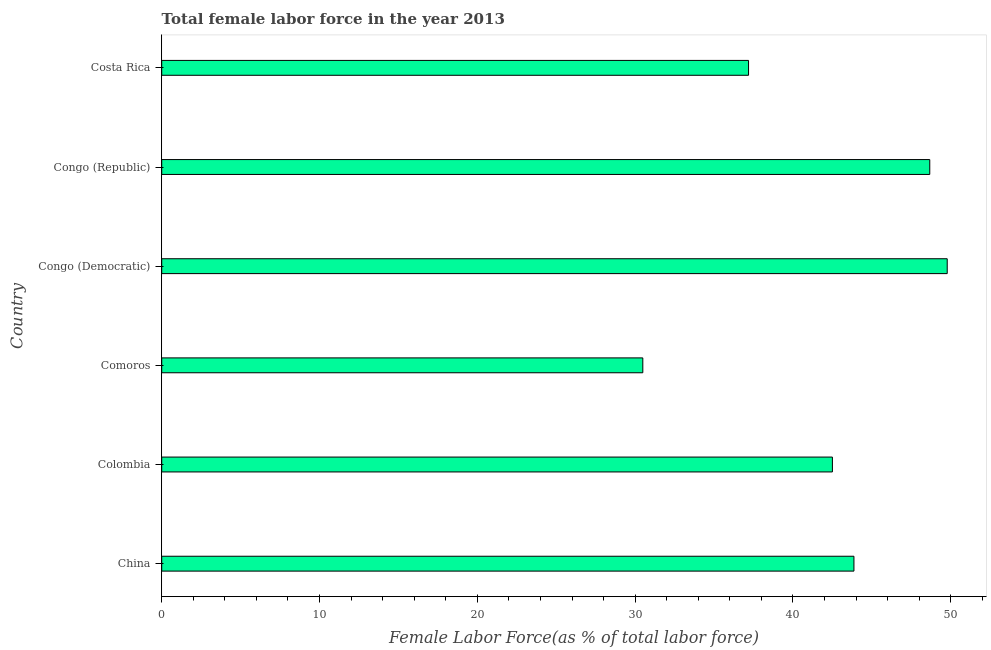Does the graph contain any zero values?
Provide a succinct answer. No. Does the graph contain grids?
Your answer should be very brief. No. What is the title of the graph?
Ensure brevity in your answer.  Total female labor force in the year 2013. What is the label or title of the X-axis?
Offer a terse response. Female Labor Force(as % of total labor force). What is the total female labor force in Congo (Democratic)?
Give a very brief answer. 49.77. Across all countries, what is the maximum total female labor force?
Your response must be concise. 49.77. Across all countries, what is the minimum total female labor force?
Offer a very short reply. 30.49. In which country was the total female labor force maximum?
Your answer should be compact. Congo (Democratic). In which country was the total female labor force minimum?
Provide a short and direct response. Comoros. What is the sum of the total female labor force?
Offer a very short reply. 252.48. What is the difference between the total female labor force in Colombia and Congo (Republic)?
Make the answer very short. -6.17. What is the average total female labor force per country?
Provide a short and direct response. 42.08. What is the median total female labor force?
Offer a terse response. 43.18. What is the ratio of the total female labor force in China to that in Congo (Democratic)?
Provide a short and direct response. 0.88. What is the difference between the highest and the second highest total female labor force?
Offer a very short reply. 1.11. Is the sum of the total female labor force in Colombia and Costa Rica greater than the maximum total female labor force across all countries?
Keep it short and to the point. Yes. What is the difference between the highest and the lowest total female labor force?
Give a very brief answer. 19.29. In how many countries, is the total female labor force greater than the average total female labor force taken over all countries?
Your answer should be very brief. 4. Are the values on the major ticks of X-axis written in scientific E-notation?
Ensure brevity in your answer.  No. What is the Female Labor Force(as % of total labor force) in China?
Your response must be concise. 43.86. What is the Female Labor Force(as % of total labor force) of Colombia?
Keep it short and to the point. 42.5. What is the Female Labor Force(as % of total labor force) in Comoros?
Give a very brief answer. 30.49. What is the Female Labor Force(as % of total labor force) of Congo (Democratic)?
Your answer should be compact. 49.77. What is the Female Labor Force(as % of total labor force) of Congo (Republic)?
Provide a short and direct response. 48.67. What is the Female Labor Force(as % of total labor force) of Costa Rica?
Your answer should be very brief. 37.19. What is the difference between the Female Labor Force(as % of total labor force) in China and Colombia?
Your answer should be very brief. 1.36. What is the difference between the Female Labor Force(as % of total labor force) in China and Comoros?
Keep it short and to the point. 13.38. What is the difference between the Female Labor Force(as % of total labor force) in China and Congo (Democratic)?
Your response must be concise. -5.91. What is the difference between the Female Labor Force(as % of total labor force) in China and Congo (Republic)?
Your response must be concise. -4.8. What is the difference between the Female Labor Force(as % of total labor force) in China and Costa Rica?
Make the answer very short. 6.68. What is the difference between the Female Labor Force(as % of total labor force) in Colombia and Comoros?
Offer a terse response. 12.01. What is the difference between the Female Labor Force(as % of total labor force) in Colombia and Congo (Democratic)?
Ensure brevity in your answer.  -7.28. What is the difference between the Female Labor Force(as % of total labor force) in Colombia and Congo (Republic)?
Keep it short and to the point. -6.17. What is the difference between the Female Labor Force(as % of total labor force) in Colombia and Costa Rica?
Offer a terse response. 5.31. What is the difference between the Female Labor Force(as % of total labor force) in Comoros and Congo (Democratic)?
Make the answer very short. -19.29. What is the difference between the Female Labor Force(as % of total labor force) in Comoros and Congo (Republic)?
Make the answer very short. -18.18. What is the difference between the Female Labor Force(as % of total labor force) in Comoros and Costa Rica?
Keep it short and to the point. -6.7. What is the difference between the Female Labor Force(as % of total labor force) in Congo (Democratic) and Congo (Republic)?
Ensure brevity in your answer.  1.11. What is the difference between the Female Labor Force(as % of total labor force) in Congo (Democratic) and Costa Rica?
Your answer should be compact. 12.59. What is the difference between the Female Labor Force(as % of total labor force) in Congo (Republic) and Costa Rica?
Offer a very short reply. 11.48. What is the ratio of the Female Labor Force(as % of total labor force) in China to that in Colombia?
Your answer should be very brief. 1.03. What is the ratio of the Female Labor Force(as % of total labor force) in China to that in Comoros?
Your answer should be very brief. 1.44. What is the ratio of the Female Labor Force(as % of total labor force) in China to that in Congo (Democratic)?
Offer a terse response. 0.88. What is the ratio of the Female Labor Force(as % of total labor force) in China to that in Congo (Republic)?
Make the answer very short. 0.9. What is the ratio of the Female Labor Force(as % of total labor force) in China to that in Costa Rica?
Offer a very short reply. 1.18. What is the ratio of the Female Labor Force(as % of total labor force) in Colombia to that in Comoros?
Make the answer very short. 1.39. What is the ratio of the Female Labor Force(as % of total labor force) in Colombia to that in Congo (Democratic)?
Your response must be concise. 0.85. What is the ratio of the Female Labor Force(as % of total labor force) in Colombia to that in Congo (Republic)?
Provide a succinct answer. 0.87. What is the ratio of the Female Labor Force(as % of total labor force) in Colombia to that in Costa Rica?
Provide a succinct answer. 1.14. What is the ratio of the Female Labor Force(as % of total labor force) in Comoros to that in Congo (Democratic)?
Offer a terse response. 0.61. What is the ratio of the Female Labor Force(as % of total labor force) in Comoros to that in Congo (Republic)?
Offer a terse response. 0.63. What is the ratio of the Female Labor Force(as % of total labor force) in Comoros to that in Costa Rica?
Give a very brief answer. 0.82. What is the ratio of the Female Labor Force(as % of total labor force) in Congo (Democratic) to that in Costa Rica?
Give a very brief answer. 1.34. What is the ratio of the Female Labor Force(as % of total labor force) in Congo (Republic) to that in Costa Rica?
Keep it short and to the point. 1.31. 